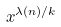Convert formula to latex. <formula><loc_0><loc_0><loc_500><loc_500>x ^ { \lambda ( n ) / k }</formula> 